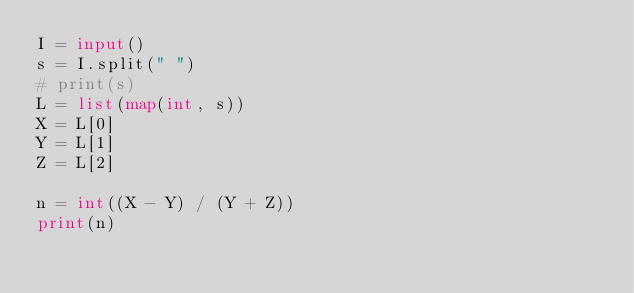<code> <loc_0><loc_0><loc_500><loc_500><_Python_>I = input()
s = I.split(" ")
# print(s)
L = list(map(int, s))
X = L[0]
Y = L[1]
Z = L[2]
 
n = int((X - Y) / (Y + Z))
print(n)</code> 